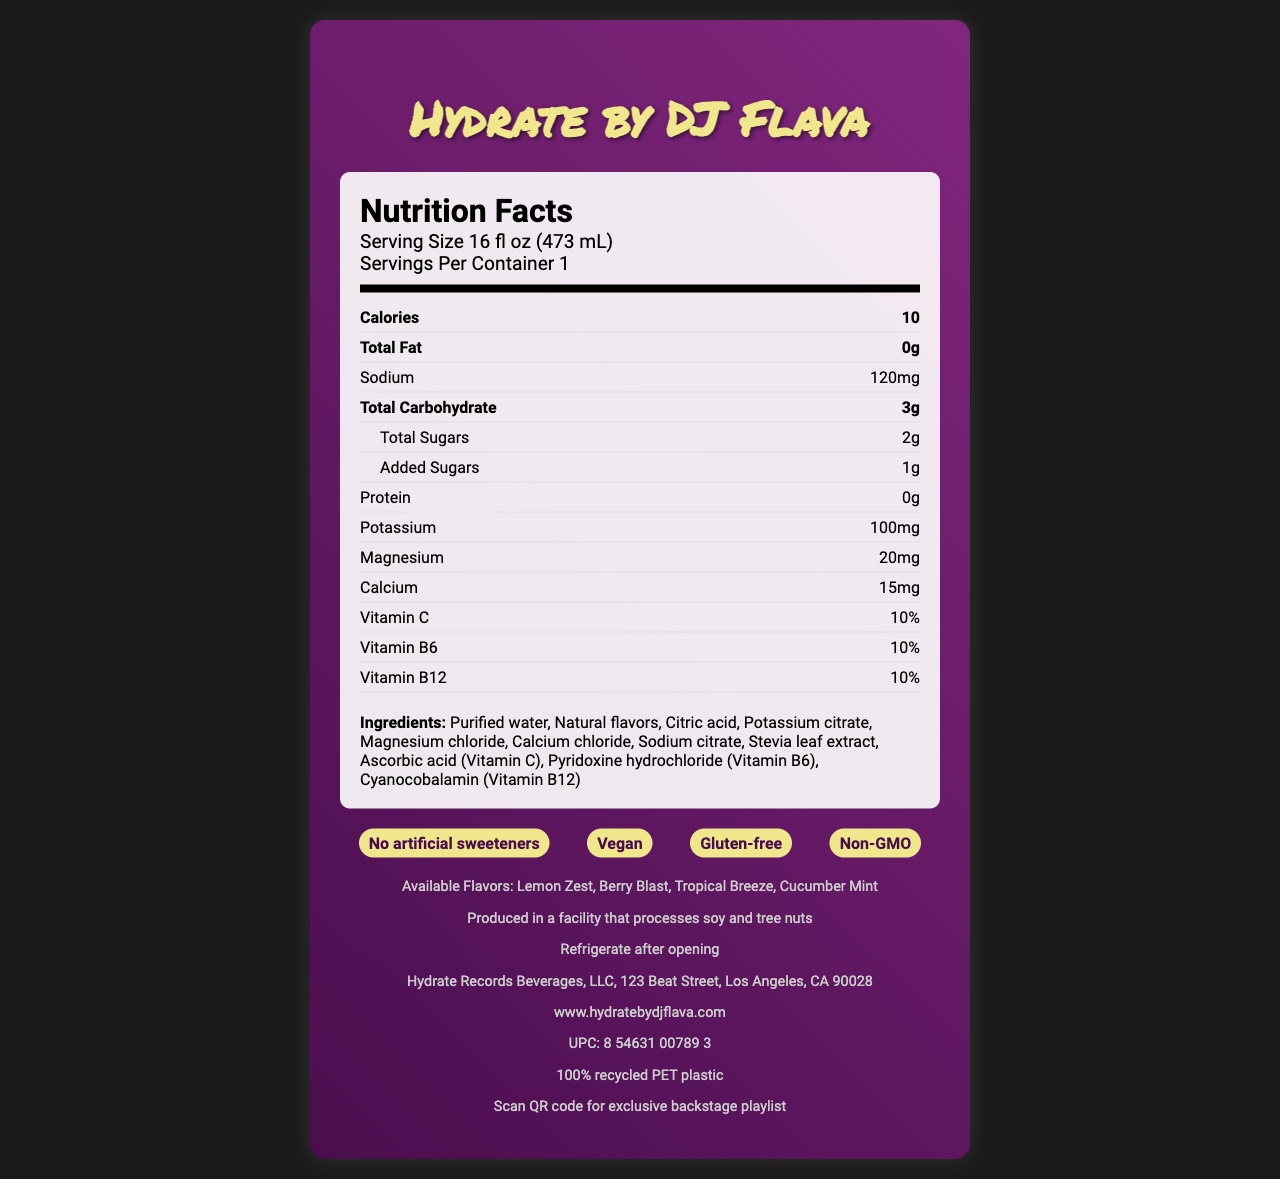what is the serving size of Hydrate by DJ Flava? The serving size is directly mentioned in the nutrition facts under the heading "Serving Size".
Answer: 16 fl oz (473 mL) how many calories are in a single serving of Hydrate by DJ Flava? The calories are listed prominently in the nutrition facts section.
Answer: 10 calories what is the amount of total sugars in this product? The total sugars are itemized in the nutrition facts section.
Answer: 2g which vitamins are present in Hydrate by DJ Flava? The vitamins listed in the nutrition facts include Vitamin C, Vitamin B6, and Vitamin B12.
Answer: Vitamin C, Vitamin B6, Vitamin B12 what are the available flavors of Hydrate by DJ Flava? The available flavors are listed at the bottom of the document.
Answer: Lemon Zest, Berry Blast, Tropical Breeze, Cucumber Mint which ingredient is used as a sweetener in Hydrate by DJ Flava? The ingredients list includes Stevia leaf extract as the sweetener.
Answer: Stevia leaf extract how much sodium does each serving of Hydrate by DJ Flava contain? The amount of sodium per serving is stated in the nutrition facts section.
Answer: 120mg how many grams of protein are in each serving of Hydrate by DJ Flava? The protein content per serving is indicated as 0g in the nutrition facts section.
Answer: 0g which of the following statements is true about Hydrate by DJ Flava?
A. It contains artificial sweeteners.
B. It is vegan.
C. It has gluten. The marketing claims include the fact that the product is vegan.
Answer: B where should Hydrate by DJ Flava be stored after opening? A. Room temperature
B. Refrigerate
C. Freezer The document advises to refrigerate the product after opening.
Answer: B Hydrate by DJ Flava is produced in a facility that processes which allergens? A. Dairy and tree nuts
B. Soy and tree nuts
C. Gluten and soy The allergen information specifically states it is produced in a facility that processes soy and tree nuts.
Answer: B is Hydrate by DJ Flava non-GMO? The marketing claims mention that the product is non-GMO.
Answer: Yes summarize the main idea of this document. The document provides a comprehensive overview of the Hydrate by DJ Flava product, including its nutritional content, ingredients, available flavors, health claims, and additional information about storage, allergens, and the manufacturer.
Answer: Hydrate by DJ Flava is a flavored water product designed for post-show hydration, featuring electrolytes and vitamins. It is marketed as vegan, gluten-free, and non-GMO, and comes in flavors like Lemon Zest, Berry Blast, Tropical Breeze, and Cucumber Mint. The nutrition facts and ingredient list are provided, along with storage and allergen information. how much Vitamin D is in Hydrate by DJ Flava? The document does not provide any information about the Vitamin D content.
Answer: Not enough information 